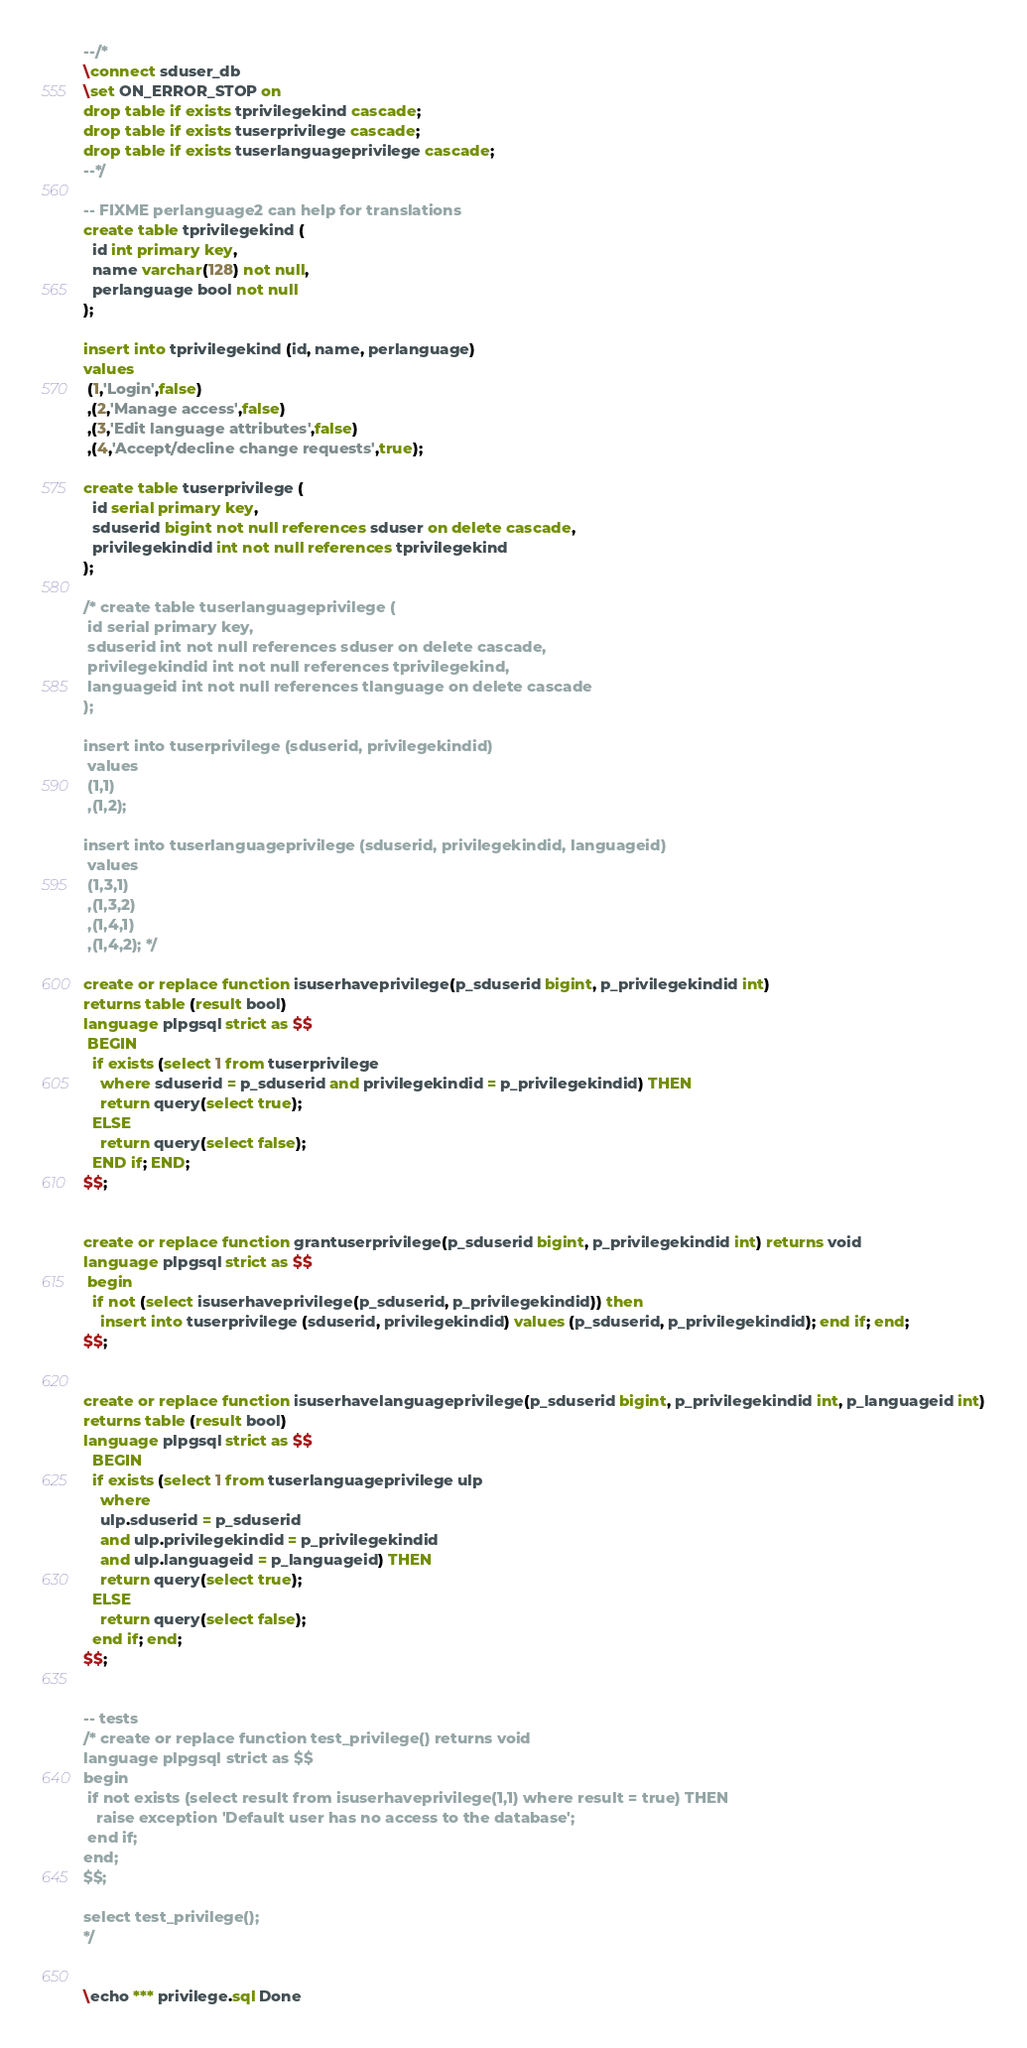Convert code to text. <code><loc_0><loc_0><loc_500><loc_500><_SQL_>
--/*
\connect sduser_db
\set ON_ERROR_STOP on
drop table if exists tprivilegekind cascade;
drop table if exists tuserprivilege cascade;
drop table if exists tuserlanguageprivilege cascade;
--*/ 

-- FIXME perlanguage2 can help for translations
create table tprivilegekind (
  id int primary key,
  name varchar(128) not null,
  perlanguage bool not null
);

insert into tprivilegekind (id, name, perlanguage)
values
 (1,'Login',false)
 ,(2,'Manage access',false)
 ,(3,'Edit language attributes',false)
 ,(4,'Accept/decline change requests',true);

create table tuserprivilege (
  id serial primary key,
  sduserid bigint not null references sduser on delete cascade,
  privilegekindid int not null references tprivilegekind
);

/* create table tuserlanguageprivilege (
 id serial primary key,
 sduserid int not null references sduser on delete cascade,
 privilegekindid int not null references tprivilegekind,
 languageid int not null references tlanguage on delete cascade
);

insert into tuserprivilege (sduserid, privilegekindid)
 values
 (1,1)
 ,(1,2); 

insert into tuserlanguageprivilege (sduserid, privilegekindid, languageid)
 values
 (1,3,1)
 ,(1,3,2)
 ,(1,4,1)
 ,(1,4,2); */

create or replace function isuserhaveprivilege(p_sduserid bigint, p_privilegekindid int)
returns table (result bool) 
language plpgsql strict as $$
 BEGIN
  if exists (select 1 from tuserprivilege 
    where sduserid = p_sduserid and privilegekindid = p_privilegekindid) THEN
    return query(select true);
  ELSE
    return query(select false);
  END if; END;
$$;


create or replace function grantuserprivilege(p_sduserid bigint, p_privilegekindid int) returns void
language plpgsql strict as $$
 begin
  if not (select isuserhaveprivilege(p_sduserid, p_privilegekindid)) then
    insert into tuserprivilege (sduserid, privilegekindid) values (p_sduserid, p_privilegekindid); end if; end;
$$;


create or replace function isuserhavelanguageprivilege(p_sduserid bigint, p_privilegekindid int, p_languageid int)
returns table (result bool)
language plpgsql strict as $$
  BEGIN
  if exists (select 1 from tuserlanguageprivilege ulp
    where 
    ulp.sduserid = p_sduserid 
    and ulp.privilegekindid = p_privilegekindid 
    and ulp.languageid = p_languageid) THEN
    return query(select true);
  ELSE
    return query(select false);
  end if; end;
$$;


-- tests
/* create or replace function test_privilege() returns void
language plpgsql strict as $$
begin
 if not exists (select result from isuserhaveprivilege(1,1) where result = true) THEN
   raise exception 'Default user has no access to the database';
 end if;
end;
$$;

select test_privilege();
*/


\echo *** privilege.sql Done
</code> 